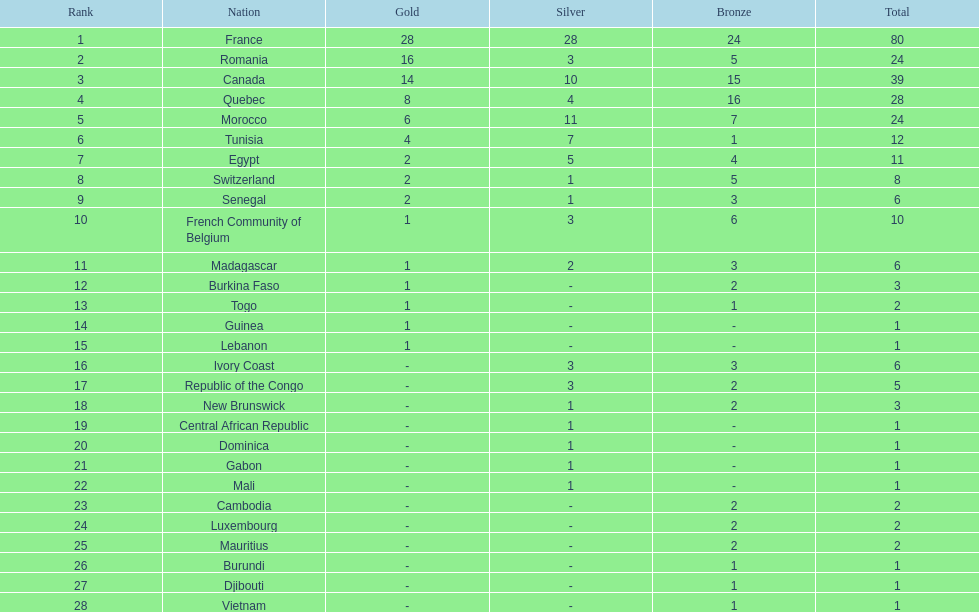What distinguishes the silver medals of france and egypt? 23. 